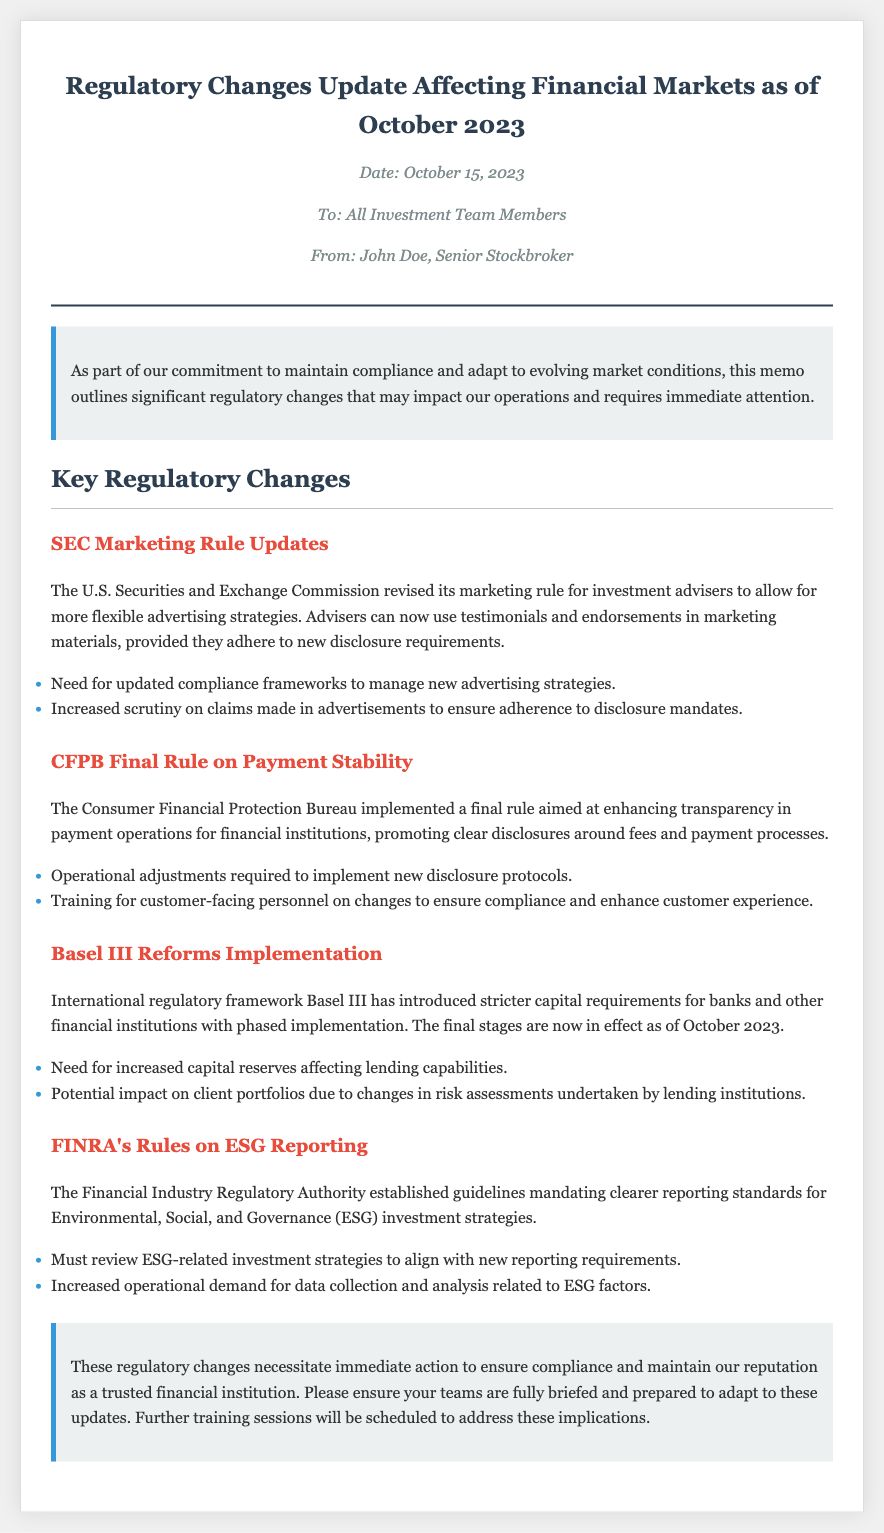What is the date of the memo? The date of the memo is explicitly stated at the top, indicating when it was created, which is October 15, 2023.
Answer: October 15, 2023 Who is the sender of the memo? The memo includes a "From" line that specifies the author of the document as John Doe, who holds the position of Senior Stockbroker.
Answer: John Doe What is the main subject of this memo? The memo's title clearly outlines the primary focus, which pertains to "Regulatory Changes Update Affecting Financial Markets."
Answer: Regulatory Changes Update Affecting Financial Markets How many key regulatory changes are discussed? By counting the sections labeled "change," the total number of key regulatory changes presented in the memo can be determined.
Answer: Four What is the implication of SEC Marketing Rule Updates? The implications of the SEC Marketing Rule updates are highlighted in the list that follows the description of the change.
Answer: Need for updated compliance frameworks to manage new advertising strategies What organization implemented the rule on payment stability? The memo specifically names the bureau responsible for the payment stability rule, which is central to this regulatory update.
Answer: Consumer Financial Protection Bureau What is one requirement resulting from the Basel III reforms? The document lists implications of the Basel III reforms that specify new requirements for financial institutions.
Answer: Increased capital reserves affecting lending capabilities What does FINRA's new guideline relate to? The memo provides a clear indication of the content focus of FINRA's new guideline, specifying its relation to investment strategies.
Answer: ESG reporting What kind of staff training is mentioned in the memo? The memo refers to a necessary type of training to ensure compliance with the updates, which indicates a focus on personnel preparedness.
Answer: Training for customer-facing personnel on changes 